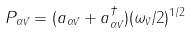Convert formula to latex. <formula><loc_0><loc_0><loc_500><loc_500>P _ { \alpha \vec { v } } = ( a _ { \alpha \vec { v } } + a ^ { \dagger } _ { \alpha \vec { v } } ) ( \omega _ { \vec { v } } / 2 ) ^ { 1 / 2 }</formula> 